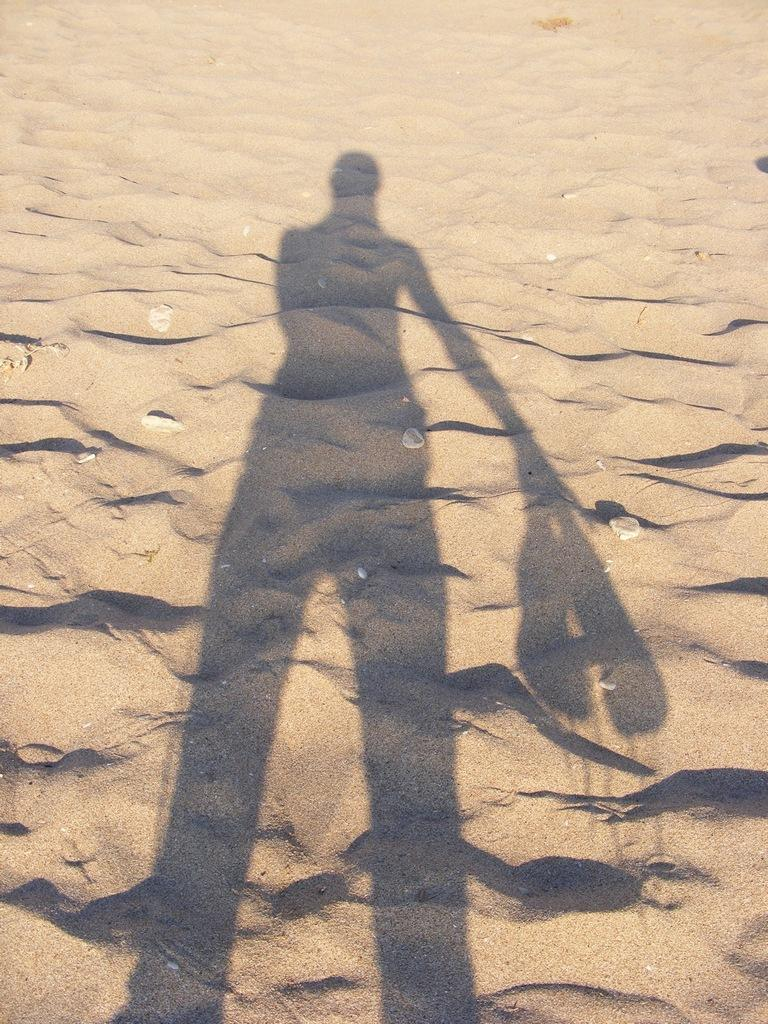What can be seen in the image that is not a solid object? There is a person's shadow in the image. What type of surface is the shadow on? The shadow is on the sand. What type of rod is being used by the beggar in the image? There is no beggar or rod present in the image; it only features a person's shadow on the sand. 